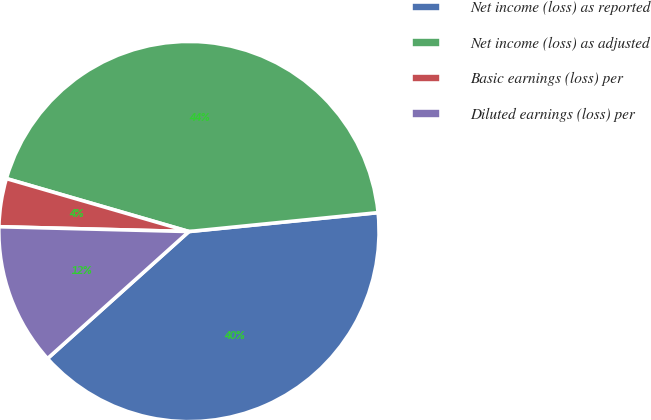Convert chart. <chart><loc_0><loc_0><loc_500><loc_500><pie_chart><fcel>Net income (loss) as reported<fcel>Net income (loss) as adjusted<fcel>Basic earnings (loss) per<fcel>Diluted earnings (loss) per<nl><fcel>39.94%<fcel>43.92%<fcel>4.09%<fcel>12.05%<nl></chart> 